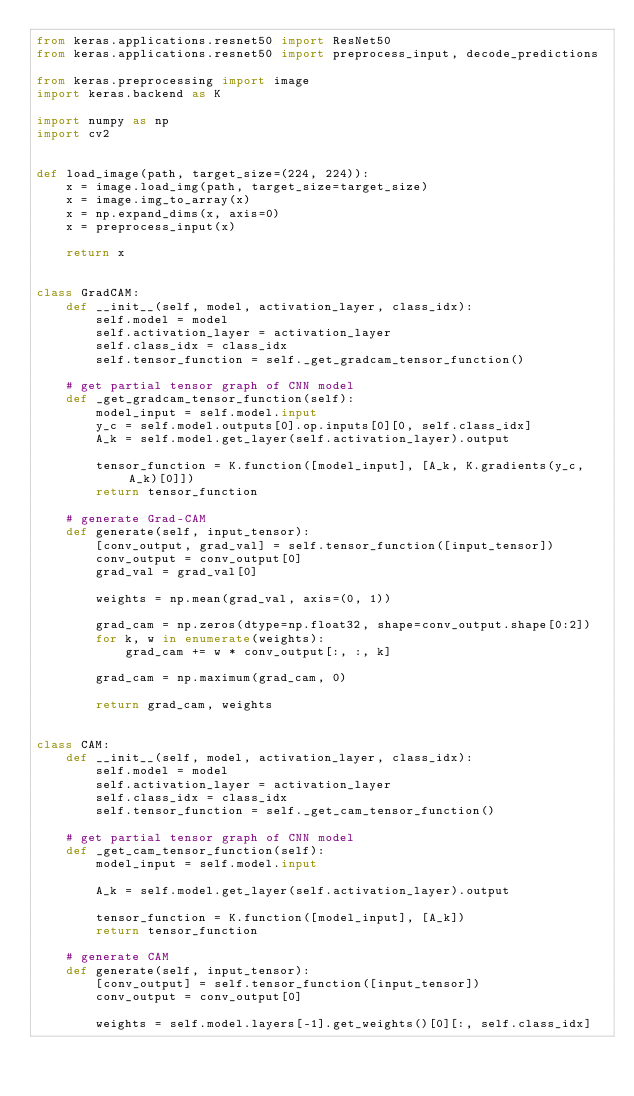Convert code to text. <code><loc_0><loc_0><loc_500><loc_500><_Python_>from keras.applications.resnet50 import ResNet50
from keras.applications.resnet50 import preprocess_input, decode_predictions

from keras.preprocessing import image
import keras.backend as K

import numpy as np
import cv2


def load_image(path, target_size=(224, 224)):
    x = image.load_img(path, target_size=target_size)
    x = image.img_to_array(x)
    x = np.expand_dims(x, axis=0)
    x = preprocess_input(x)

    return x


class GradCAM:
    def __init__(self, model, activation_layer, class_idx):
        self.model = model
        self.activation_layer = activation_layer
        self.class_idx = class_idx
        self.tensor_function = self._get_gradcam_tensor_function()

    # get partial tensor graph of CNN model
    def _get_gradcam_tensor_function(self):
        model_input = self.model.input
        y_c = self.model.outputs[0].op.inputs[0][0, self.class_idx]
        A_k = self.model.get_layer(self.activation_layer).output

        tensor_function = K.function([model_input], [A_k, K.gradients(y_c, A_k)[0]])
        return tensor_function

    # generate Grad-CAM
    def generate(self, input_tensor):
        [conv_output, grad_val] = self.tensor_function([input_tensor])
        conv_output = conv_output[0]
        grad_val = grad_val[0]

        weights = np.mean(grad_val, axis=(0, 1))

        grad_cam = np.zeros(dtype=np.float32, shape=conv_output.shape[0:2])
        for k, w in enumerate(weights):
            grad_cam += w * conv_output[:, :, k]

        grad_cam = np.maximum(grad_cam, 0)

        return grad_cam, weights


class CAM:
    def __init__(self, model, activation_layer, class_idx):
        self.model = model
        self.activation_layer = activation_layer
        self.class_idx = class_idx
        self.tensor_function = self._get_cam_tensor_function()

    # get partial tensor graph of CNN model
    def _get_cam_tensor_function(self):
        model_input = self.model.input

        A_k = self.model.get_layer(self.activation_layer).output

        tensor_function = K.function([model_input], [A_k])
        return tensor_function

    # generate CAM
    def generate(self, input_tensor):
        [conv_output] = self.tensor_function([input_tensor])
        conv_output = conv_output[0]

        weights = self.model.layers[-1].get_weights()[0][:, self.class_idx]
</code> 